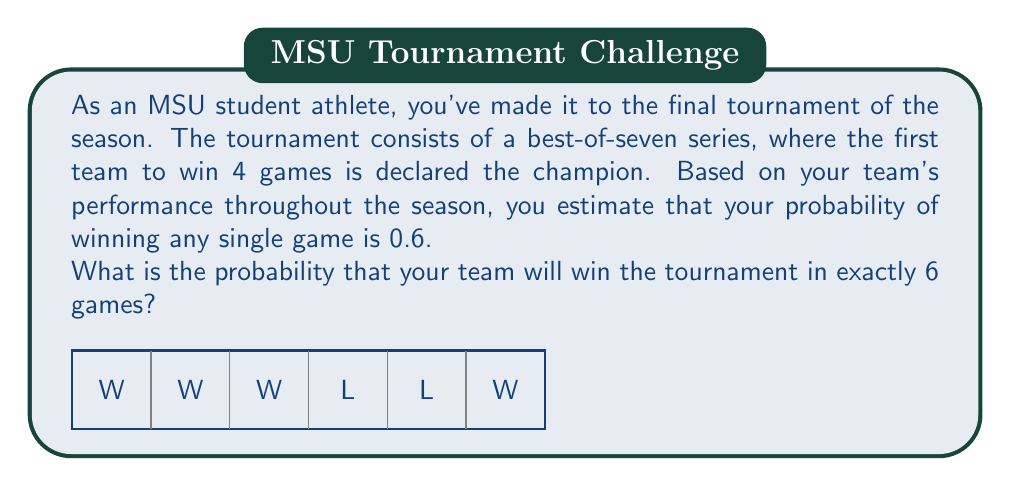Can you solve this math problem? Let's approach this step-by-step:

1) To win in exactly 6 games, your team needs to win 3 out of the first 5 games and then win the 6th game.

2) The probability of winning any single game is 0.6, so the probability of losing is 1 - 0.6 = 0.4.

3) We need to calculate:
   a) The probability of winning 3 out of 5 games
   b) The probability of winning the 6th game
   c) Multiply these probabilities

4) For part (a), we can use the binomial probability formula:
   $$ P(X = k) = \binom{n}{k} p^k (1-p)^{n-k} $$
   Where n = 5, k = 3, p = 0.6

   $$ P(3 \text{ wins in 5 games}) = \binom{5}{3} (0.6)^3 (0.4)^2 $$

5) Calculate:
   $$ \binom{5}{3} = 10 $$
   $$ (0.6)^3 = 0.216 $$
   $$ (0.4)^2 = 0.16 $$

   $$ 10 * 0.216 * 0.16 = 0.3456 $$

6) The probability of winning the 6th game is simply 0.6

7) Therefore, the final probability is:
   $$ 0.3456 * 0.6 = 0.20736 $$
Answer: $0.20736$ or $20.736\%$ 